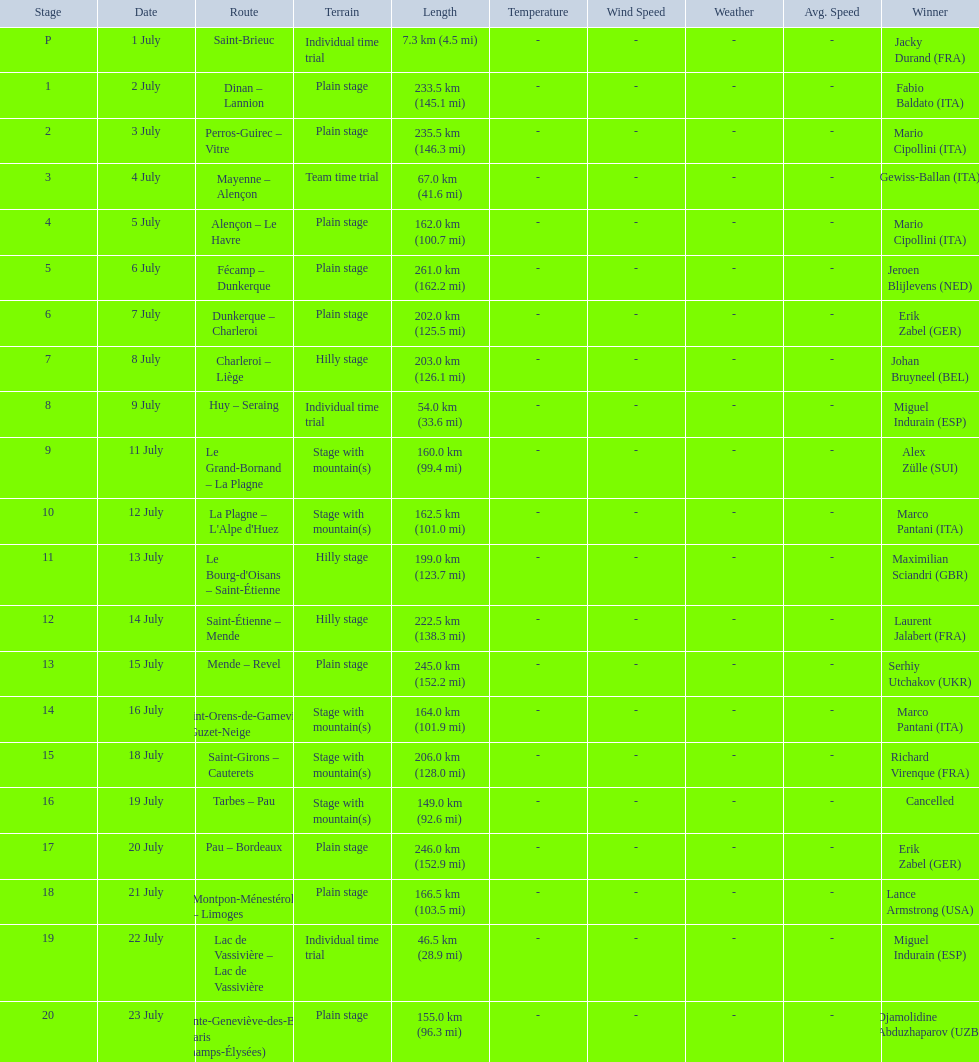What were the dates of the 1995 tour de france? 1 July, 2 July, 3 July, 4 July, 5 July, 6 July, 7 July, 8 July, 9 July, 11 July, 12 July, 13 July, 14 July, 15 July, 16 July, 18 July, 19 July, 20 July, 21 July, 22 July, 23 July. What was the length for july 8th? 203.0 km (126.1 mi). 